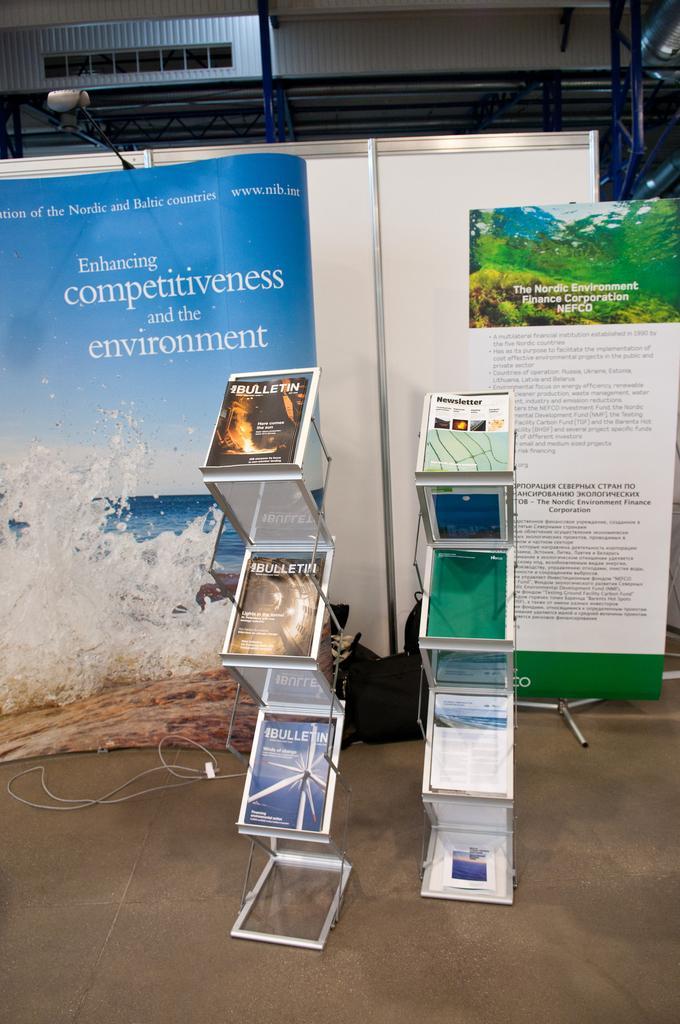Could you give a brief overview of what you see in this image? In this image I can see two metal stands and few books in the stands and in the background I can see few banners, few wires, few metal rods and the building. 